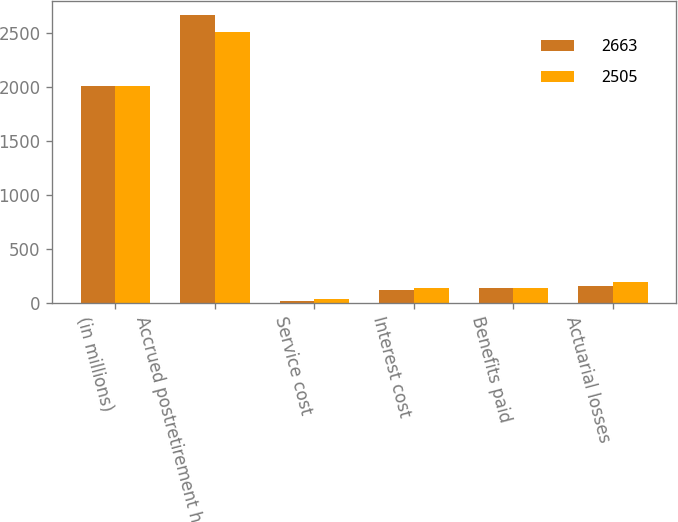<chart> <loc_0><loc_0><loc_500><loc_500><stacked_bar_chart><ecel><fcel>(in millions)<fcel>Accrued postretirement health<fcel>Service cost<fcel>Interest cost<fcel>Benefits paid<fcel>Actuarial losses<nl><fcel>2663<fcel>2012<fcel>2663<fcel>18<fcel>115<fcel>135<fcel>160<nl><fcel>2505<fcel>2011<fcel>2505<fcel>34<fcel>139<fcel>136<fcel>191<nl></chart> 